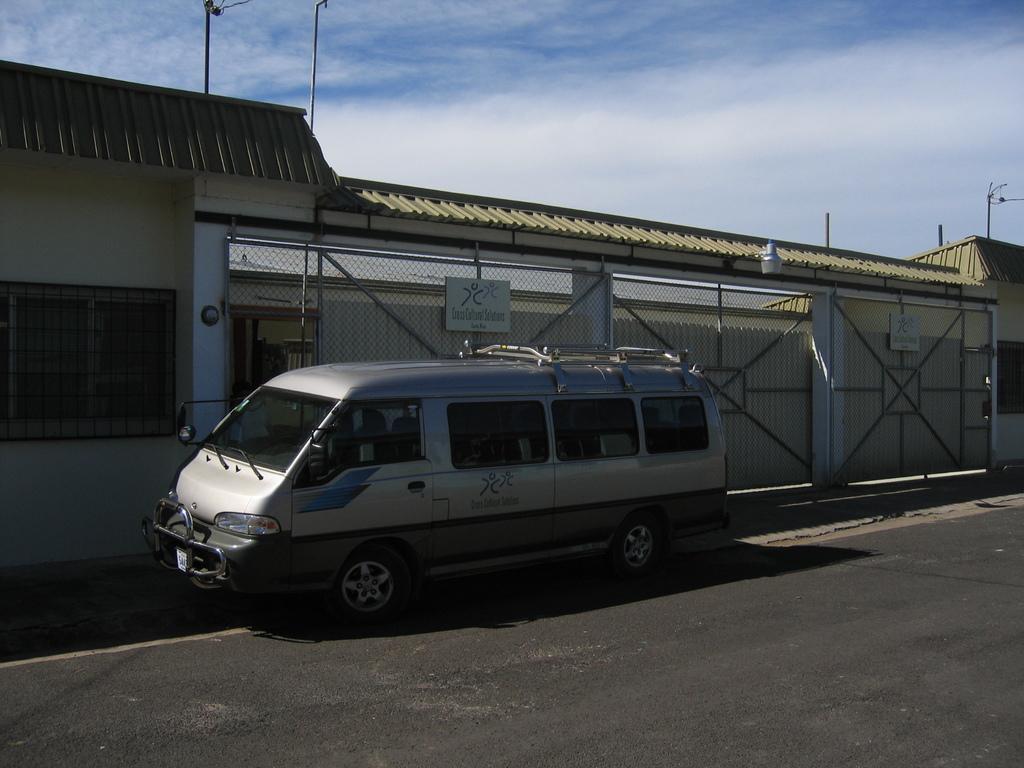Please provide a concise description of this image. In this image we can see a vehicle on the road. In the background we can see walls, roofs, boards on the gates, poles and clouds in the sky. 